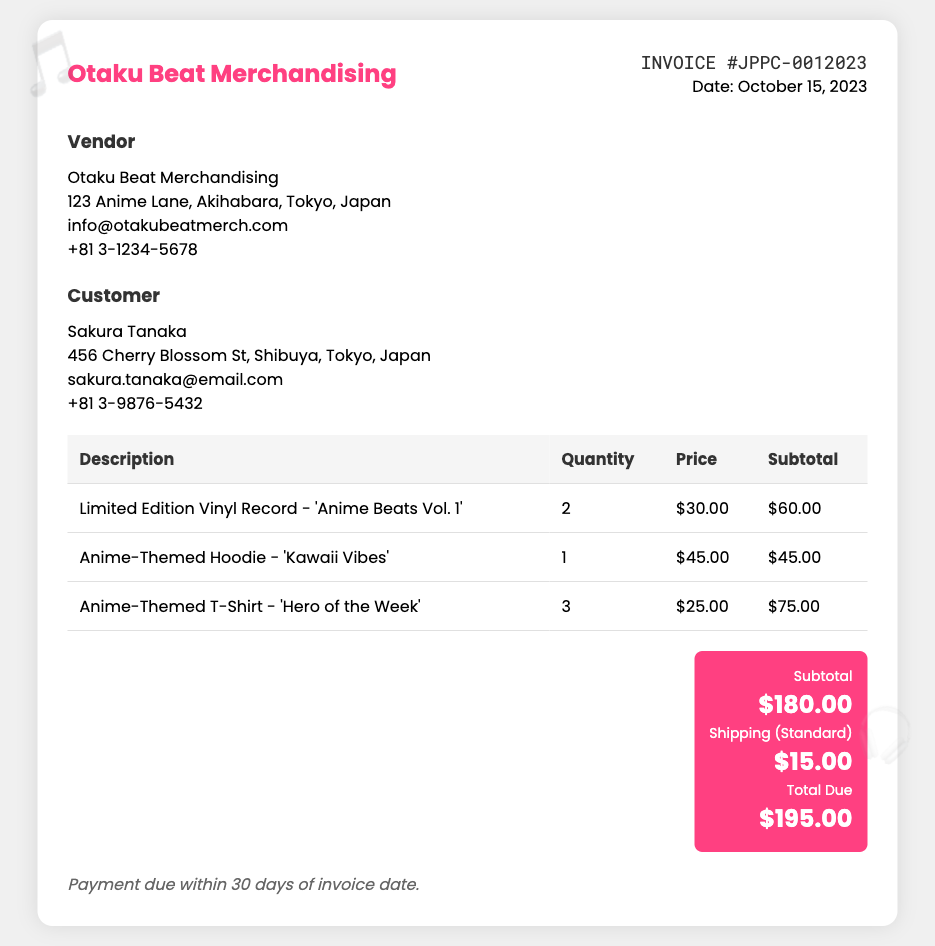What is the invoice number? The invoice number is clearly stated in the document, indicated as JPPC-0012023.
Answer: JPPC-0012023 Who is the vendor? The vendor's name and details are provided in the document, identifying them as Otaku Beat Merchandising.
Answer: Otaku Beat Merchandising What is the total due amount? The total amount due is calculated from the subtotals and shipping costs, which is reported as $195.00.
Answer: $195.00 How many Vinyl Records were purchased? The document specifies that 2 Limited Edition Vinyl Records were purchased, as seen in the itemized list.
Answer: 2 What is the price of the Anime-Themed Hoodie? The price for the Anime-Themed Hoodie is explicitly listed in the invoice as $45.00.
Answer: $45.00 What is the shipping cost? The invoice states the standard shipping cost, which is listed as $15.00.
Answer: $15.00 When is the payment due? The payment terms indicate that payment is due within 30 days of the invoice date.
Answer: 30 days How many items in total were purchased? The total quantity of items listed includes 2 Vinyl Records, 1 Hoodie, and 3 T-Shirts, summing up to 6 items in total.
Answer: 6 Which customer is listed on the invoice? The document identifies the customer by the name Sakura Tanaka, included in the customer section.
Answer: Sakura Tanaka 